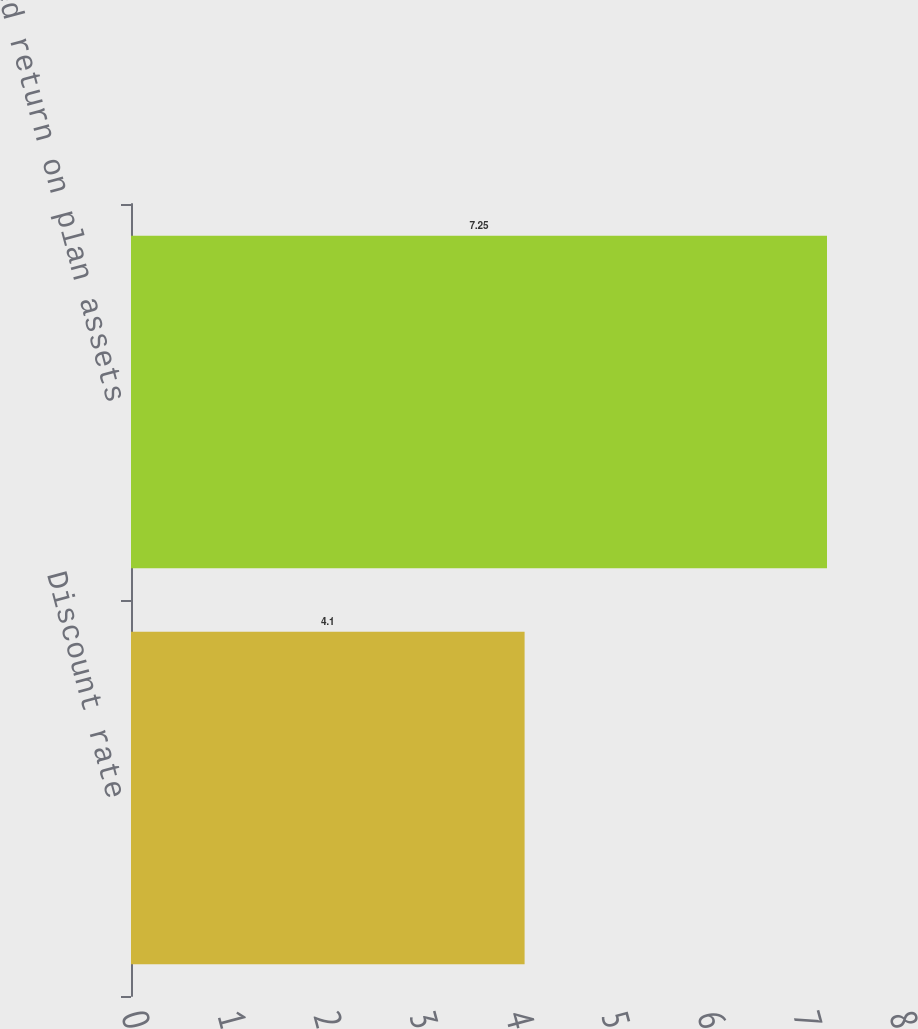Convert chart. <chart><loc_0><loc_0><loc_500><loc_500><bar_chart><fcel>Discount rate<fcel>Expected return on plan assets<nl><fcel>4.1<fcel>7.25<nl></chart> 